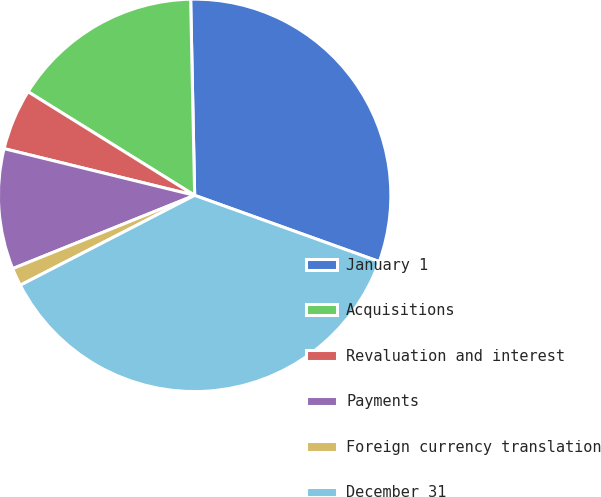<chart> <loc_0><loc_0><loc_500><loc_500><pie_chart><fcel>January 1<fcel>Acquisitions<fcel>Revaluation and interest<fcel>Payments<fcel>Foreign currency translation<fcel>December 31<nl><fcel>30.81%<fcel>15.82%<fcel>5.03%<fcel>9.92%<fcel>1.48%<fcel>36.94%<nl></chart> 